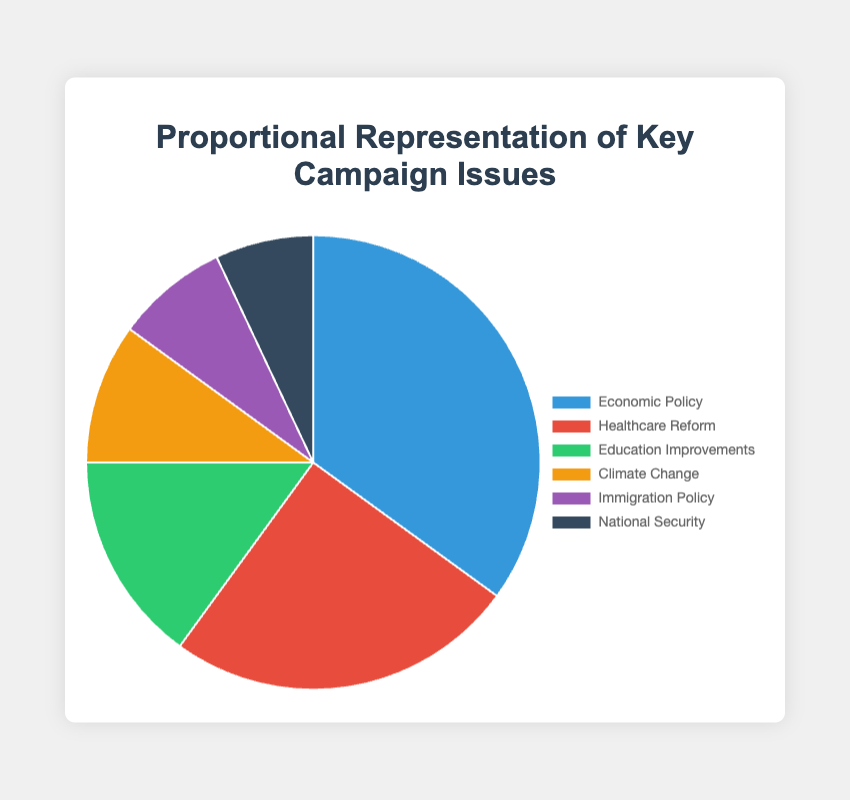What is the most important campaign issue according to the figure? The chart shows that "Economic Policy" has the highest percentage, indicating it is the most important campaign issue.
Answer: Economic Policy What percentage of people are concerned with Climate Change and National Security combined? According to the figure, Climate Change is 10% and National Security is 7%. Adding these together, 10% + 7% = 17%.
Answer: 17% Which issue has a higher percentage, Education Improvements or Healthcare Reform? The figure indicates that Healthcare Reform is at 25%, whereas Education Improvements is at 15%. Therefore, Healthcare Reform has a higher percentage.
Answer: Healthcare Reform What is the least important campaign issue based on the figure? The issue with the lowest percentage in the figure is National Security, which is at 7%.
Answer: National Security What is the difference in percentage between Economic Policy and Immigration Policy? The figure shows Economic Policy at 35% and Immigration Policy at 8%. The difference is calculated as 35% - 8% = 27%.
Answer: 27% Which issues together account for more than half of the total percentages? Economic Policy is 35% and Healthcare Reform is 25%. Together, 35% + 25% = 60%, which is more than half (50%).
Answer: Economic Policy and Healthcare Reform What is the visual color representing Healthcare Reform in the pie chart? In the pie chart, Healthcare Reform is represented by the color red.
Answer: Red How much higher is the percentage of people concerned with Education Improvements compared to National Security? Education Improvements is 15% and National Security is 7%. The difference is 15% - 7% = 8%.
Answer: 8% What is the total percentage of issues other than the top two (Economic Policy and Healthcare Reform)? The top two issues are Economic Policy (35%) and Healthcare Reform (25%). The sum of the other issues is calculated as 100% - 35% - 25% = 40%.
Answer: 40% Which section of the pie chart is represented in purple? According to the figure and its associated color-coding, Immigration Policy is represented in purple.
Answer: Immigration Policy 